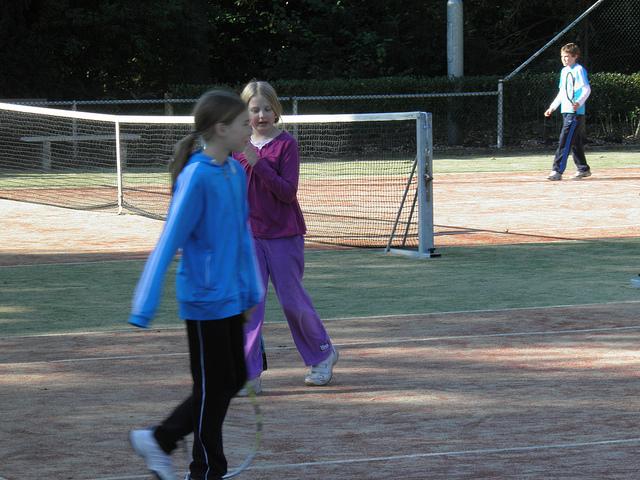Are these people taking lessons?
Give a very brief answer. No. What is the boy in the background holding?
Short answer required. Tennis racket. What color jacket does the girl with the ponytail have on?
Keep it brief. Blue. Are they inside?
Keep it brief. No. What game is being played?
Keep it brief. Tennis. 